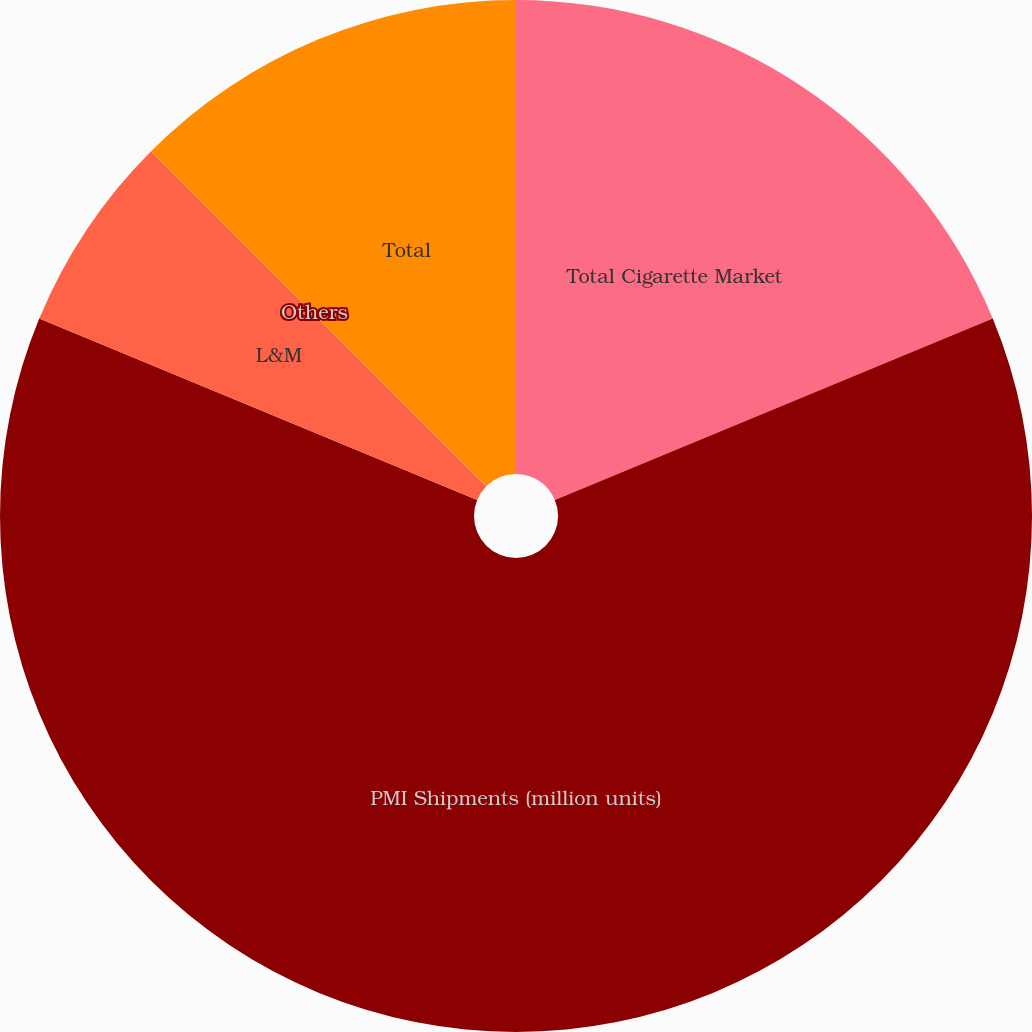Convert chart to OTSL. <chart><loc_0><loc_0><loc_500><loc_500><pie_chart><fcel>Total Cigarette Market<fcel>PMI Shipments (million units)<fcel>L&M<fcel>Others<fcel>Total<nl><fcel>18.75%<fcel>62.49%<fcel>6.25%<fcel>0.0%<fcel>12.5%<nl></chart> 